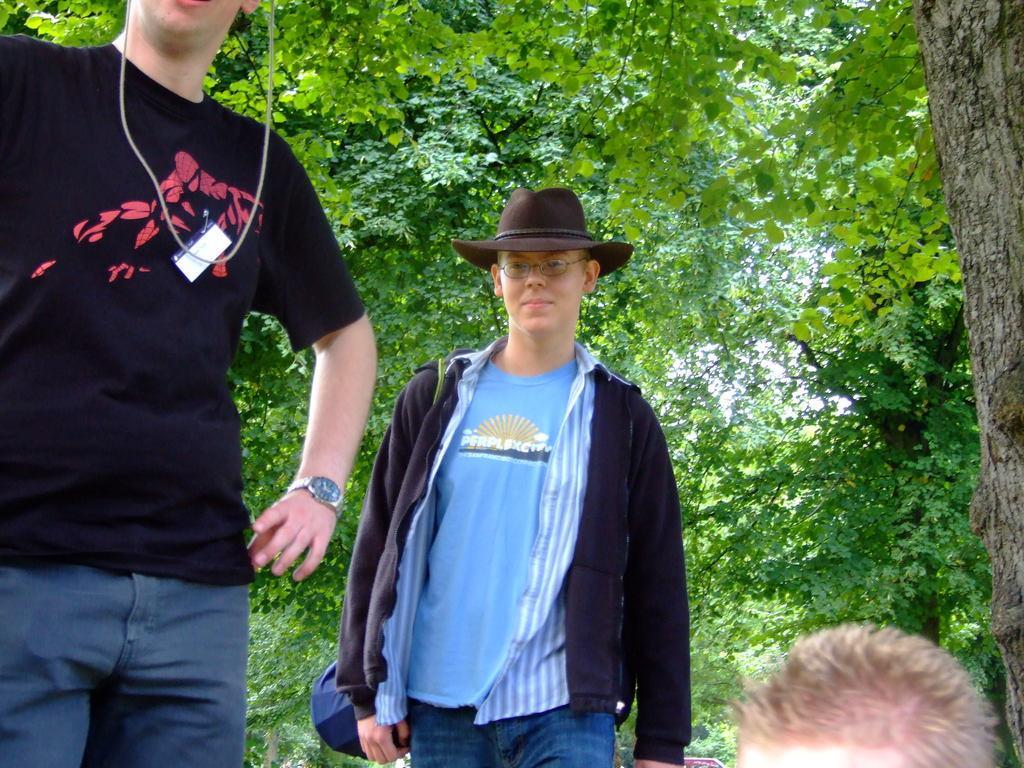Describe this image in one or two sentences. In this image we can see this person wearing black T-shirt and watch to his hand, also we can see this person wearing black color sweater, shirt, T-shirt, spectacles and hat and also we can see this person head. In the background, we can see trees. 